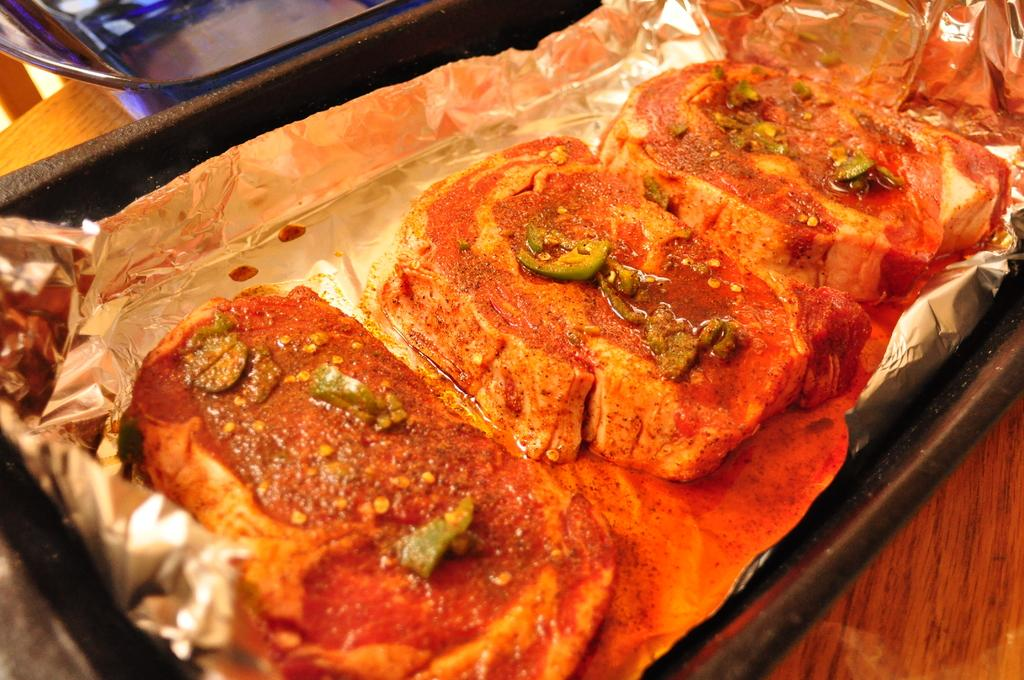What type of items can be seen in the image? There are food items in the image. How is the aluminum foil arranged in the image? The aluminum foil is in a tray in the image. Where is the tray with aluminum foil located? The tray is placed on a table in the image. What can be seen in the background of the image? There is an object visible in the background of the image. What type of feeling does the stone in the image evoke? There is no stone present in the image, so it cannot evoke any feelings. 